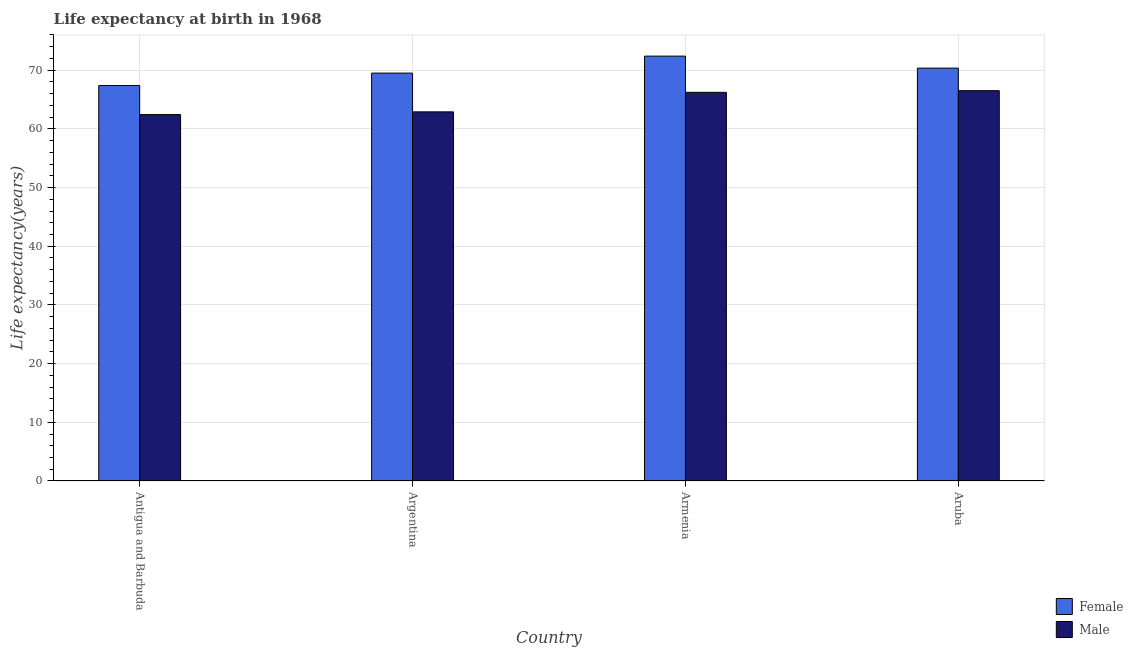How many different coloured bars are there?
Your response must be concise. 2. What is the label of the 1st group of bars from the left?
Make the answer very short. Antigua and Barbuda. In how many cases, is the number of bars for a given country not equal to the number of legend labels?
Offer a very short reply. 0. What is the life expectancy(male) in Antigua and Barbuda?
Keep it short and to the point. 62.43. Across all countries, what is the maximum life expectancy(female)?
Provide a succinct answer. 72.39. Across all countries, what is the minimum life expectancy(male)?
Offer a very short reply. 62.43. In which country was the life expectancy(female) maximum?
Provide a short and direct response. Armenia. In which country was the life expectancy(male) minimum?
Offer a terse response. Antigua and Barbuda. What is the total life expectancy(male) in the graph?
Give a very brief answer. 258.04. What is the difference between the life expectancy(female) in Antigua and Barbuda and that in Aruba?
Provide a short and direct response. -2.97. What is the difference between the life expectancy(male) in Antigua and Barbuda and the life expectancy(female) in Aruba?
Your response must be concise. -7.92. What is the average life expectancy(male) per country?
Keep it short and to the point. 64.51. What is the difference between the life expectancy(female) and life expectancy(male) in Argentina?
Offer a very short reply. 6.6. What is the ratio of the life expectancy(male) in Antigua and Barbuda to that in Aruba?
Keep it short and to the point. 0.94. Is the difference between the life expectancy(male) in Armenia and Aruba greater than the difference between the life expectancy(female) in Armenia and Aruba?
Provide a short and direct response. No. What is the difference between the highest and the second highest life expectancy(male)?
Your answer should be very brief. 0.28. What is the difference between the highest and the lowest life expectancy(female)?
Give a very brief answer. 5.01. What does the 2nd bar from the left in Antigua and Barbuda represents?
Keep it short and to the point. Male. How many bars are there?
Offer a terse response. 8. Are the values on the major ticks of Y-axis written in scientific E-notation?
Make the answer very short. No. Does the graph contain any zero values?
Your answer should be compact. No. Where does the legend appear in the graph?
Ensure brevity in your answer.  Bottom right. What is the title of the graph?
Your answer should be compact. Life expectancy at birth in 1968. Does "Depositors" appear as one of the legend labels in the graph?
Provide a short and direct response. No. What is the label or title of the Y-axis?
Offer a terse response. Life expectancy(years). What is the Life expectancy(years) of Female in Antigua and Barbuda?
Keep it short and to the point. 67.38. What is the Life expectancy(years) in Male in Antigua and Barbuda?
Provide a short and direct response. 62.43. What is the Life expectancy(years) in Female in Argentina?
Ensure brevity in your answer.  69.5. What is the Life expectancy(years) in Male in Argentina?
Your answer should be compact. 62.89. What is the Life expectancy(years) of Female in Armenia?
Give a very brief answer. 72.39. What is the Life expectancy(years) in Male in Armenia?
Provide a succinct answer. 66.22. What is the Life expectancy(years) of Female in Aruba?
Your answer should be very brief. 70.34. What is the Life expectancy(years) in Male in Aruba?
Ensure brevity in your answer.  66.5. Across all countries, what is the maximum Life expectancy(years) in Female?
Give a very brief answer. 72.39. Across all countries, what is the maximum Life expectancy(years) in Male?
Offer a very short reply. 66.5. Across all countries, what is the minimum Life expectancy(years) in Female?
Keep it short and to the point. 67.38. Across all countries, what is the minimum Life expectancy(years) of Male?
Ensure brevity in your answer.  62.43. What is the total Life expectancy(years) of Female in the graph?
Your answer should be very brief. 279.61. What is the total Life expectancy(years) of Male in the graph?
Your response must be concise. 258.04. What is the difference between the Life expectancy(years) in Female in Antigua and Barbuda and that in Argentina?
Your answer should be very brief. -2.12. What is the difference between the Life expectancy(years) of Male in Antigua and Barbuda and that in Argentina?
Your answer should be compact. -0.47. What is the difference between the Life expectancy(years) in Female in Antigua and Barbuda and that in Armenia?
Your answer should be very brief. -5.01. What is the difference between the Life expectancy(years) in Male in Antigua and Barbuda and that in Armenia?
Keep it short and to the point. -3.79. What is the difference between the Life expectancy(years) of Female in Antigua and Barbuda and that in Aruba?
Give a very brief answer. -2.97. What is the difference between the Life expectancy(years) in Male in Antigua and Barbuda and that in Aruba?
Make the answer very short. -4.08. What is the difference between the Life expectancy(years) of Female in Argentina and that in Armenia?
Your response must be concise. -2.89. What is the difference between the Life expectancy(years) of Male in Argentina and that in Armenia?
Your answer should be compact. -3.33. What is the difference between the Life expectancy(years) of Female in Argentina and that in Aruba?
Give a very brief answer. -0.85. What is the difference between the Life expectancy(years) in Male in Argentina and that in Aruba?
Your response must be concise. -3.61. What is the difference between the Life expectancy(years) of Female in Armenia and that in Aruba?
Provide a succinct answer. 2.04. What is the difference between the Life expectancy(years) of Male in Armenia and that in Aruba?
Ensure brevity in your answer.  -0.28. What is the difference between the Life expectancy(years) in Female in Antigua and Barbuda and the Life expectancy(years) in Male in Argentina?
Your answer should be very brief. 4.49. What is the difference between the Life expectancy(years) in Female in Antigua and Barbuda and the Life expectancy(years) in Male in Armenia?
Ensure brevity in your answer.  1.16. What is the difference between the Life expectancy(years) of Female in Argentina and the Life expectancy(years) of Male in Armenia?
Ensure brevity in your answer.  3.27. What is the difference between the Life expectancy(years) in Female in Argentina and the Life expectancy(years) in Male in Aruba?
Offer a very short reply. 2.99. What is the difference between the Life expectancy(years) in Female in Armenia and the Life expectancy(years) in Male in Aruba?
Keep it short and to the point. 5.89. What is the average Life expectancy(years) of Female per country?
Offer a terse response. 69.9. What is the average Life expectancy(years) in Male per country?
Provide a short and direct response. 64.51. What is the difference between the Life expectancy(years) in Female and Life expectancy(years) in Male in Antigua and Barbuda?
Provide a short and direct response. 4.95. What is the difference between the Life expectancy(years) of Female and Life expectancy(years) of Male in Argentina?
Ensure brevity in your answer.  6.6. What is the difference between the Life expectancy(years) of Female and Life expectancy(years) of Male in Armenia?
Your answer should be very brief. 6.17. What is the difference between the Life expectancy(years) of Female and Life expectancy(years) of Male in Aruba?
Offer a very short reply. 3.84. What is the ratio of the Life expectancy(years) of Female in Antigua and Barbuda to that in Argentina?
Give a very brief answer. 0.97. What is the ratio of the Life expectancy(years) in Female in Antigua and Barbuda to that in Armenia?
Your answer should be compact. 0.93. What is the ratio of the Life expectancy(years) in Male in Antigua and Barbuda to that in Armenia?
Provide a short and direct response. 0.94. What is the ratio of the Life expectancy(years) in Female in Antigua and Barbuda to that in Aruba?
Your response must be concise. 0.96. What is the ratio of the Life expectancy(years) of Male in Antigua and Barbuda to that in Aruba?
Provide a short and direct response. 0.94. What is the ratio of the Life expectancy(years) in Female in Argentina to that in Armenia?
Provide a succinct answer. 0.96. What is the ratio of the Life expectancy(years) of Male in Argentina to that in Armenia?
Your answer should be very brief. 0.95. What is the ratio of the Life expectancy(years) of Female in Argentina to that in Aruba?
Give a very brief answer. 0.99. What is the ratio of the Life expectancy(years) in Male in Argentina to that in Aruba?
Offer a terse response. 0.95. What is the ratio of the Life expectancy(years) in Female in Armenia to that in Aruba?
Make the answer very short. 1.03. What is the ratio of the Life expectancy(years) of Male in Armenia to that in Aruba?
Give a very brief answer. 1. What is the difference between the highest and the second highest Life expectancy(years) in Female?
Offer a very short reply. 2.04. What is the difference between the highest and the second highest Life expectancy(years) of Male?
Offer a terse response. 0.28. What is the difference between the highest and the lowest Life expectancy(years) of Female?
Ensure brevity in your answer.  5.01. What is the difference between the highest and the lowest Life expectancy(years) of Male?
Keep it short and to the point. 4.08. 